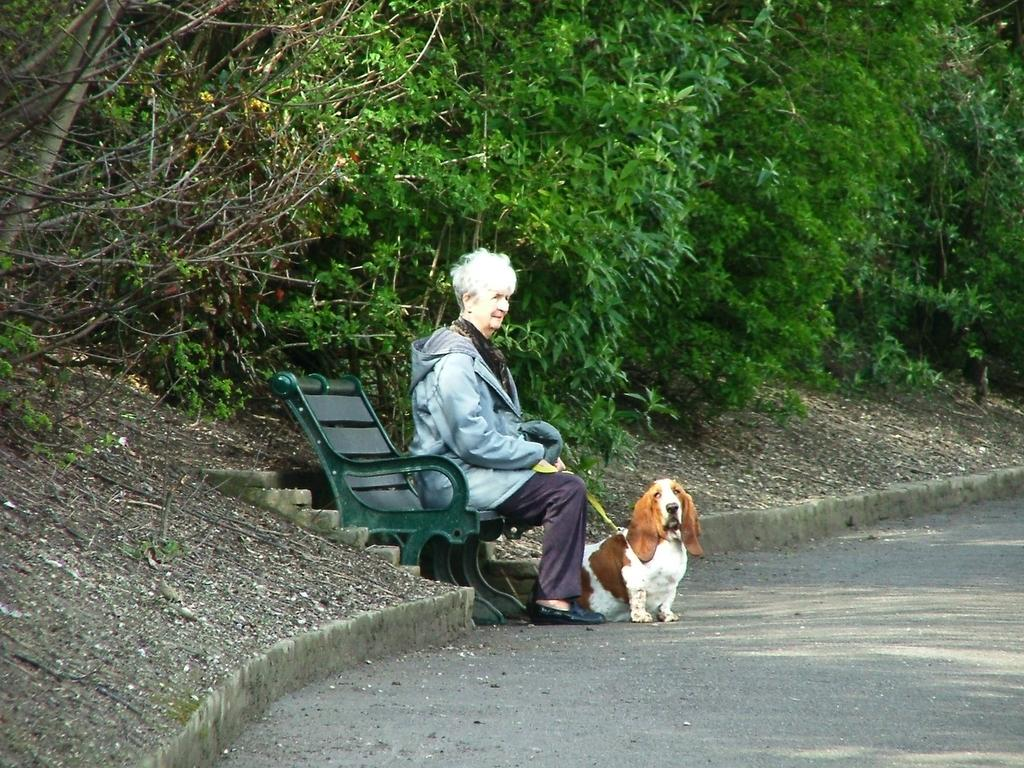What type of vegetation can be seen in the image? There are trees in the image. Where are the trees located in the image? The trees are at the top of the image. What piece of furniture is in the middle of the image? There is a bench in the middle of the image. Who is sitting on the bench? A lady is sitting on the bench. What is the lady holding? The lady is holding a dog. What is the lady wearing? The lady is wearing a sweater. How many cows are present in the image? There are no cows present in the image. What type of line is visible in the image? There is no line visible in the image. 